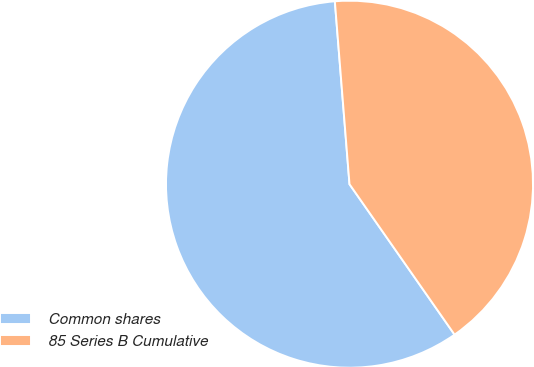<chart> <loc_0><loc_0><loc_500><loc_500><pie_chart><fcel>Common shares<fcel>85 Series B Cumulative<nl><fcel>58.43%<fcel>41.57%<nl></chart> 